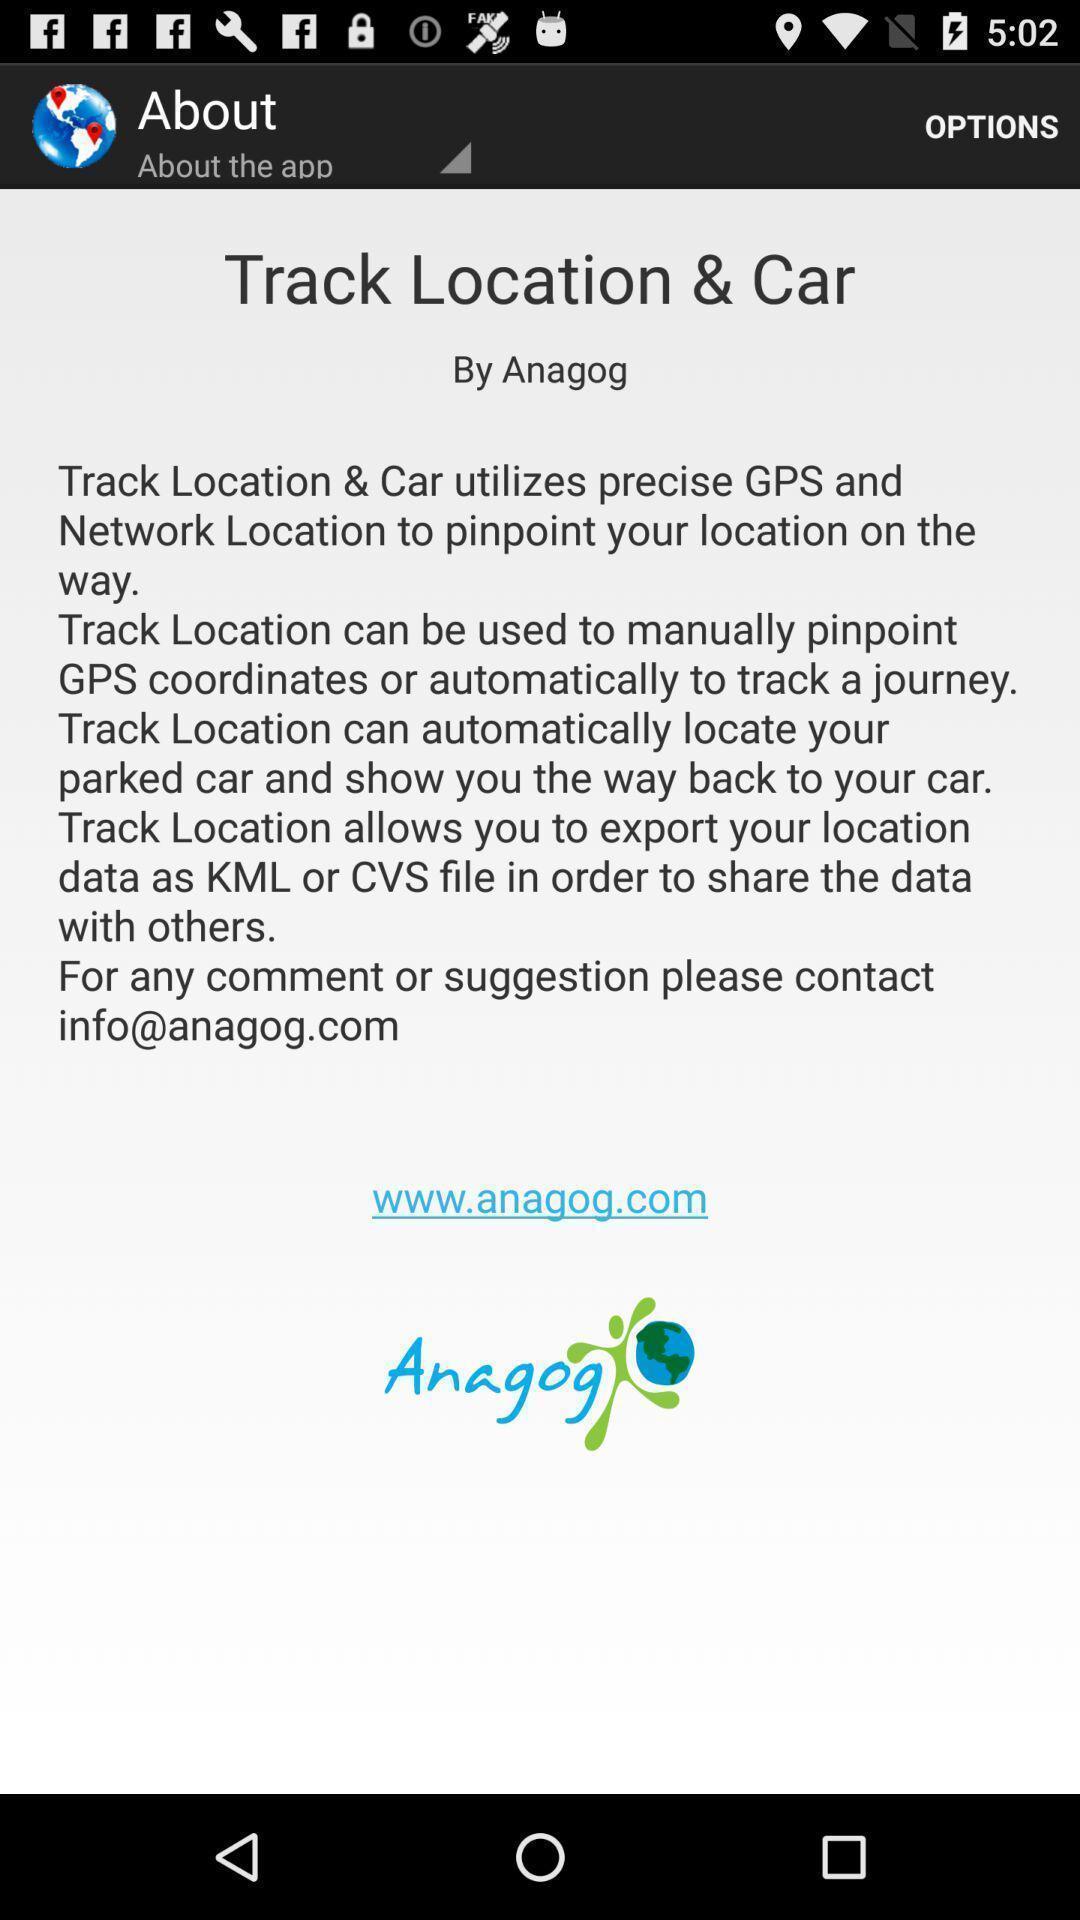Summarize the main components in this picture. Page displaying the information of track location and car. 